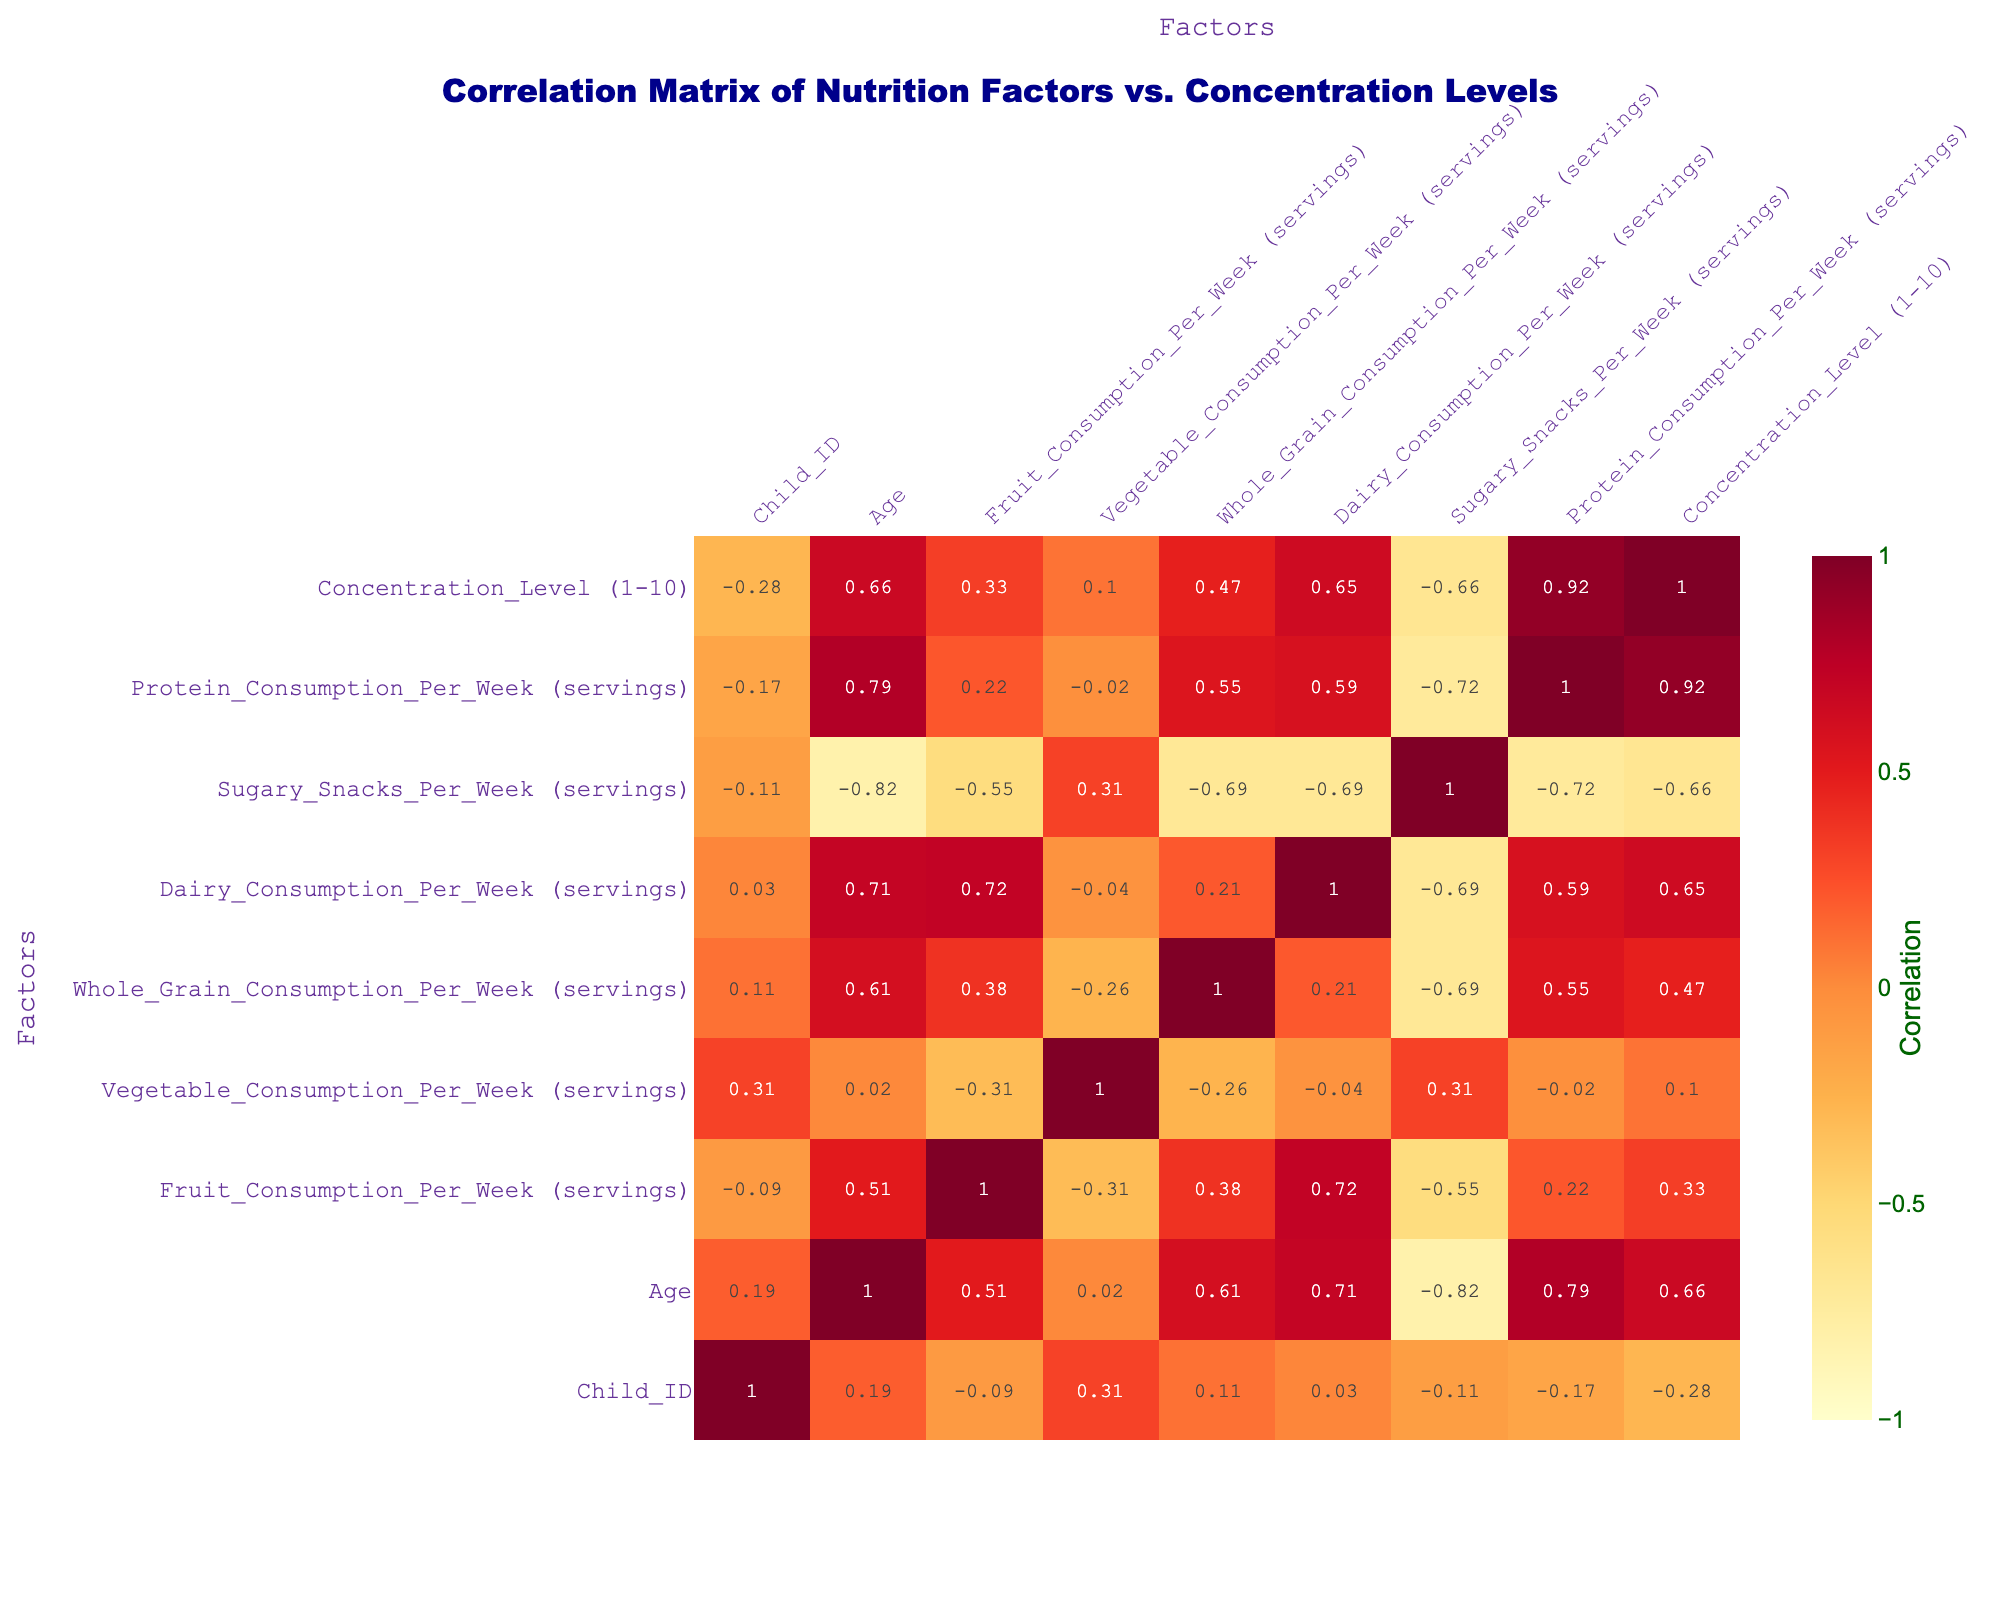What is the correlation between fruit consumption and concentration levels? From the correlation table, we can look at the value in the intersection of "Fruit_Consumption_Per_Week (servings)" and "Concentration_Level (1-10)." This value is 0.47, indicating a moderate positive correlation; as fruit consumption increases, concentration levels also tend to increase.
Answer: 0.47 What is the average concentration level of children consuming more than 10 servings of fruit per week? First, we identify the children with fruit consumption greater than 10 servings per week: Child 1 (8), Child 2 (7), Child 5 (10), Child 7 (11), and Child 8 (12). Their concentration levels are 8, 7, 8, 9, and 7, respectively. The sum is 39, and there are 5 children, so the average concentration level is 39/5 = 7.8.
Answer: 7.8 Is there a negative correlation between sugary snacks consumption and concentration levels? The table shows the correlation value between "Sugary_Snacks_Per_Week (servings)" and "Concentration_Level (1-10)" is -0.61. A negative value indicates that as the consumption of sugary snacks increases, concentration levels tend to decrease. Therefore, the statement is true.
Answer: Yes Which nutrition factor has the strongest correlation with concentration levels? By examining the values in the correlation table, the highest correlation value with "Concentration_Level (1-10)" is 0.62 for "Vegetable_Consumption_Per_Week (servings)," indicating it has the strongest positive correlation with concentration levels compared to other factors in the dataset.
Answer: Vegetable consumption What is the difference in average concentration levels between children consuming less than 5 servings of dairy and those consuming 5 servings or more? First, we determine the two groups: those consuming less than 5 servings of dairy (Child 4 and Child 6 with concentration levels 6 and 5, respectively) average to (6 + 5)/2 = 5.5. For those consuming 5 servings or more (all other children), the concentration levels are 8, 7, 9, 8, and 7, which averages to (8 + 7 + 9 + 8 + 7)/5 = 7.8. The difference between the two averages is 7.8 - 5.5 = 2.3.
Answer: 2.3 Are concentration levels higher on average for children who eat more whole grains? Analyzing children who consume more than 5 servings of whole grains (Child 1, Child 2, Child 5, and Child 7), we find their concentration levels are 8, 7, 8, and 9, respectively, averaging (8 + 7 + 8 + 9)/4 = 8. The average concentration level of those eating less (Child 3, Child 4, Child 6, Child 8, Child 9, and Child 10) is 7. The average for whole grain consumers is higher, confirming the statement is true.
Answer: Yes 